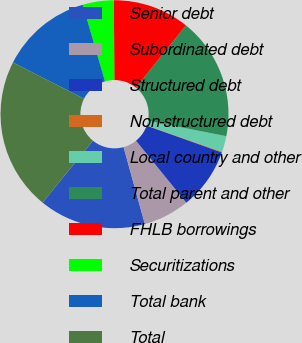Convert chart to OTSL. <chart><loc_0><loc_0><loc_500><loc_500><pie_chart><fcel>Senior debt<fcel>Subordinated debt<fcel>Structured debt<fcel>Non-structured debt<fcel>Local country and other<fcel>Total parent and other<fcel>FHLB borrowings<fcel>Securitizations<fcel>Total bank<fcel>Total<nl><fcel>15.16%<fcel>6.56%<fcel>8.71%<fcel>0.1%<fcel>2.25%<fcel>17.32%<fcel>10.86%<fcel>4.41%<fcel>13.01%<fcel>21.62%<nl></chart> 